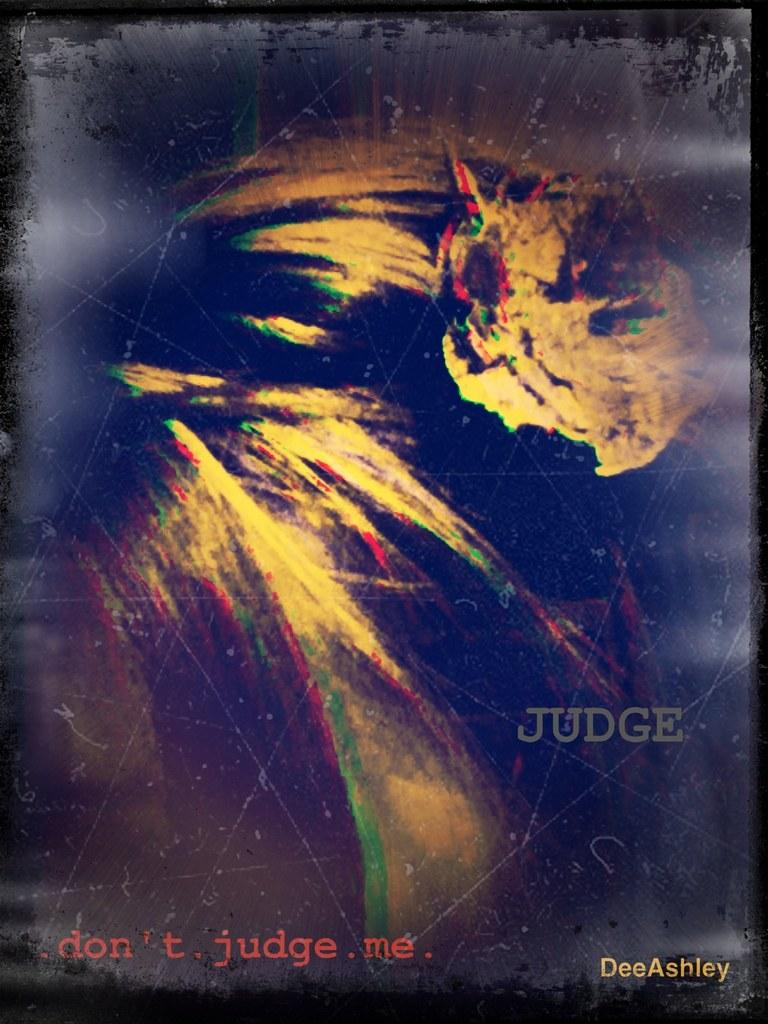<image>
Present a compact description of the photo's key features. A piece of art by DeeAshley with the words 'JUDGE' and '.don't. judge . me .' 